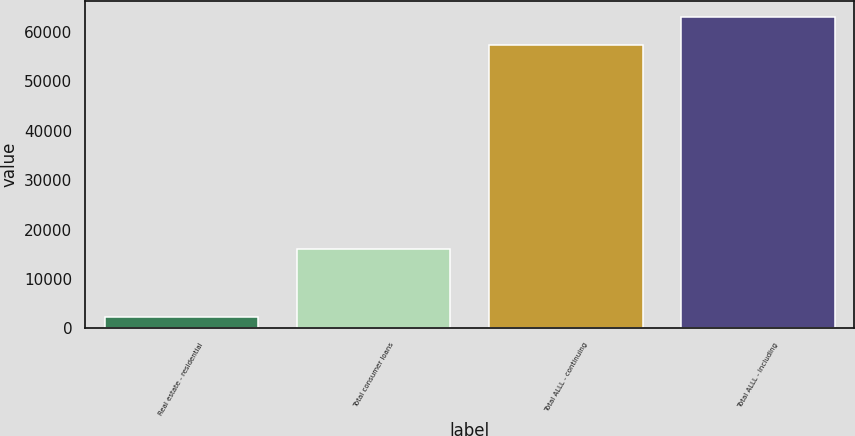Convert chart. <chart><loc_0><loc_0><loc_500><loc_500><bar_chart><fcel>Real estate - residential<fcel>Total consumer loans<fcel>Total ALLL - continuing<fcel>Total ALLL - including<nl><fcel>2225<fcel>16000<fcel>57381<fcel>63126.1<nl></chart> 